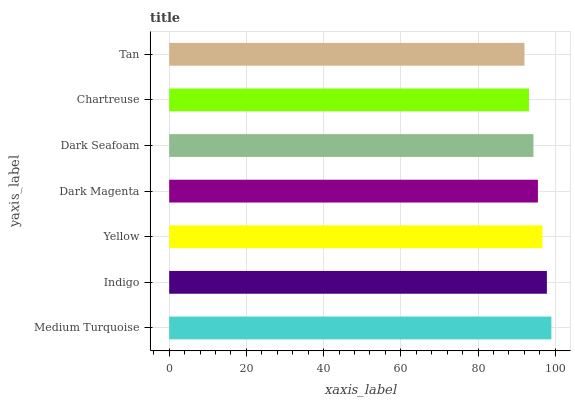Is Tan the minimum?
Answer yes or no. Yes. Is Medium Turquoise the maximum?
Answer yes or no. Yes. Is Indigo the minimum?
Answer yes or no. No. Is Indigo the maximum?
Answer yes or no. No. Is Medium Turquoise greater than Indigo?
Answer yes or no. Yes. Is Indigo less than Medium Turquoise?
Answer yes or no. Yes. Is Indigo greater than Medium Turquoise?
Answer yes or no. No. Is Medium Turquoise less than Indigo?
Answer yes or no. No. Is Dark Magenta the high median?
Answer yes or no. Yes. Is Dark Magenta the low median?
Answer yes or no. Yes. Is Tan the high median?
Answer yes or no. No. Is Indigo the low median?
Answer yes or no. No. 